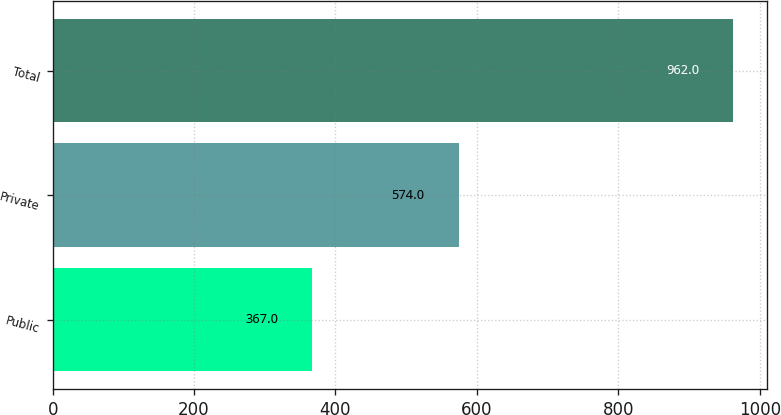<chart> <loc_0><loc_0><loc_500><loc_500><bar_chart><fcel>Public<fcel>Private<fcel>Total<nl><fcel>367<fcel>574<fcel>962<nl></chart> 